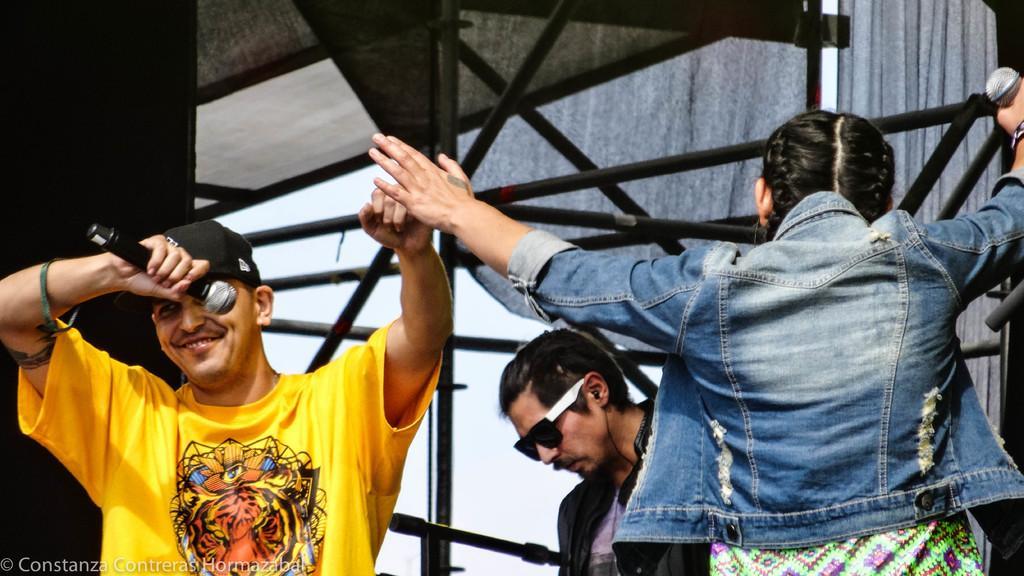Can you describe this image briefly? There are people and these two people holding microphones. In the background we can see rods, wall and curtains. In the bottom left side of the image we can see watermark. 